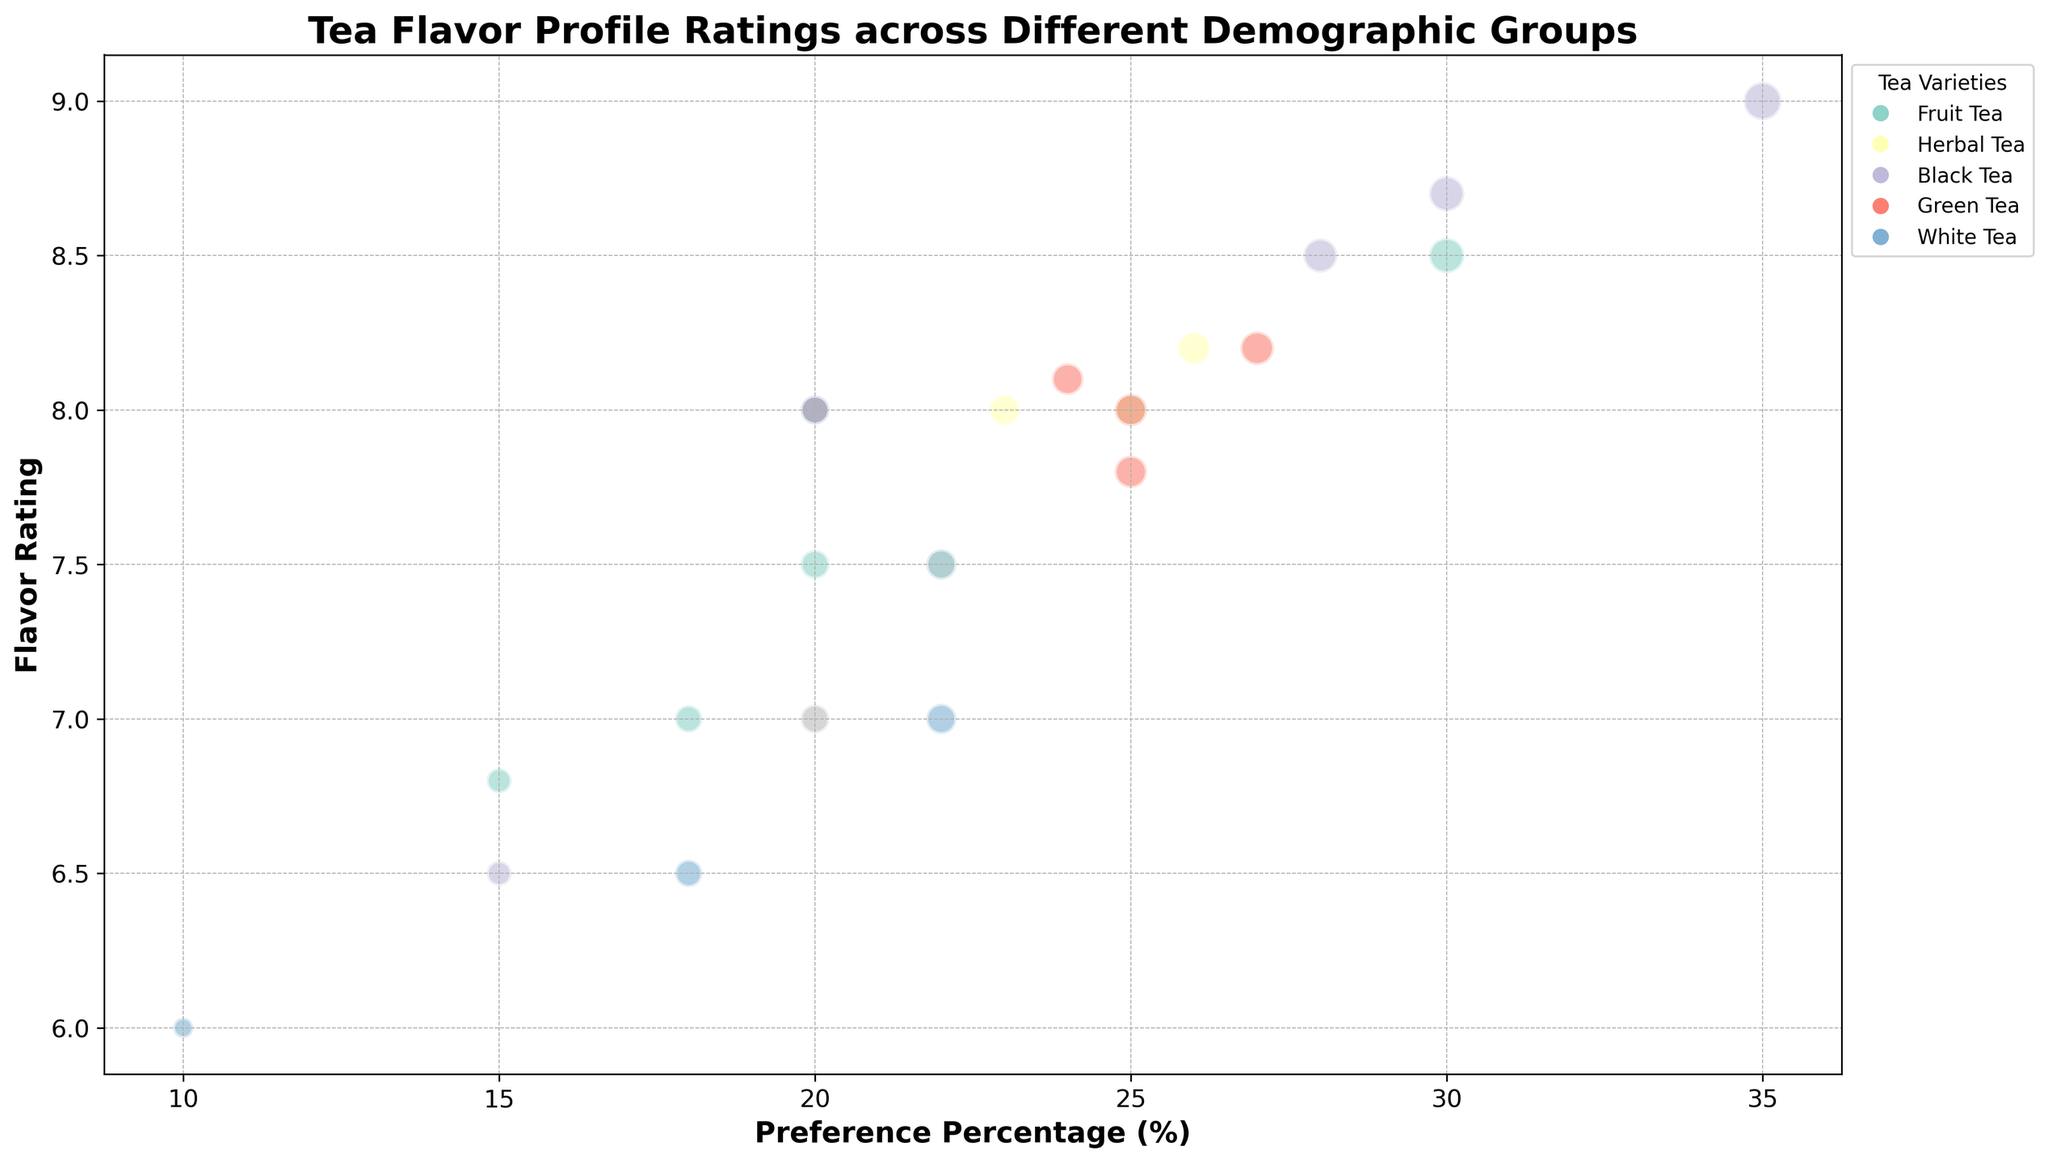Which demographic group has the highest flavor rating for Black Tea? First, look at the bubbles representing Black Tea in each demographic group. The demographic group 60+ has the highest flavor rating of 9.0.
Answer: 60+ What is the difference in preference percentage between the 18-25 and 46-60 demographic groups for Herbal Tea? Find the preference percentage for Herbal Tea in both demographic groups: 20% for 18-25 and 26% for 46-60. The difference is 26% - 20% = 6%.
Answer: 6% Which tea variety has the highest bubble size in the 26-35 demographic group? Look at the bubbles for each tea variety in the 26-35 demographic group and compare their sizes. The highest bubble size is Green Tea with a size of 270.
Answer: Green Tea What is the average flavor rating for Green Tea across all demographic groups? Add the flavor ratings for Green Tea across all groups: 7.8, 8.2, 8.0, 8.1, 8.0. Then divide by the number of groups: (7.8 + 8.2 + 8.0 + 8.1 + 8.0) / 5 = 8.02.
Answer: 8.02 How does the preference percentage for Fruit Tea in the 18-25 demographic compare to White Tea in the same group? First, find the preference percentages: 30% for Fruit Tea and 10% for White Tea in the 18-25 group. Compare 30% and 10%. Fruit Tea has a higher preference percentage.
Answer: Fruit Tea has a higher preference Which tea variety has the most consistent flavor rating across all demographic groups? Compare the range of flavor ratings for each tea variety across demographic groups. Herbal Tea's flavor ratings range from 7.0 to 8.2, which is relatively consistent compared to others.
Answer: Herbal Tea Among the demographic groups, which one shows the most interest (largest bubble size) in Black Tea? Look at the bubbles representing Black Tea in each demographic group and determine the largest bubble size. The 60+ demographic group shows the most interest with a bubble size of 350.
Answer: 60+ What's the flavor rating of Herbal Tea in the 46-60 demographic group, and what is its bubble size? Check the bubble for the 46-60 demographic group and Herbal Tea. The flavor rating is 8.2, and the bubble size is 260.
Answer: 8.2, 260 